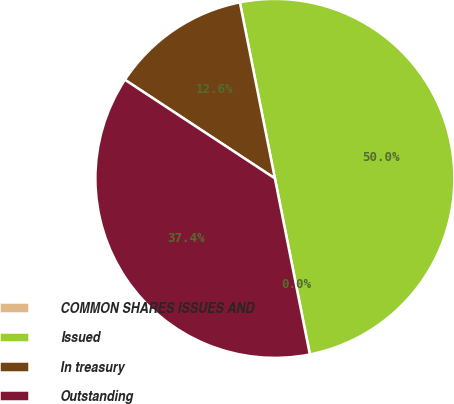Convert chart. <chart><loc_0><loc_0><loc_500><loc_500><pie_chart><fcel>COMMON SHARES ISSUES AND<fcel>Issued<fcel>In treasury<fcel>Outstanding<nl><fcel>0.01%<fcel>50.0%<fcel>12.62%<fcel>37.38%<nl></chart> 